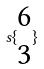<formula> <loc_0><loc_0><loc_500><loc_500>s \{ \begin{matrix} 6 \\ 3 \end{matrix} \}</formula> 